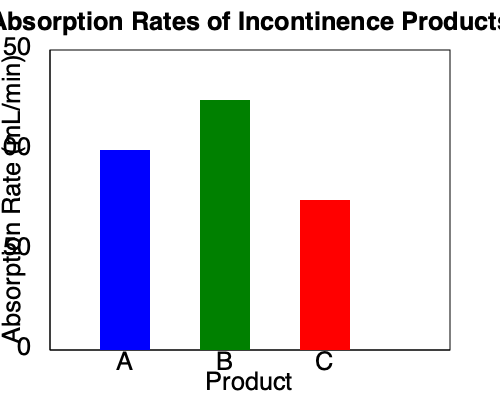Based on the bar graph comparing the absorption rates of different incontinence products, which product has the highest absorption rate, and what is the approximate difference in absorption rate between the best and worst performing products? To answer this question, we need to analyze the bar graph:

1. Identify the products:
   - Product A (blue bar)
   - Product B (green bar)
   - Product C (red bar)

2. Compare the heights of the bars:
   - Product A: Approximately 100 mL/min
   - Product B: Approximately 125 mL/min
   - Product C: Approximately 75 mL/min

3. Determine the product with the highest absorption rate:
   Product B has the tallest bar, indicating the highest absorption rate.

4. Calculate the difference between the best and worst performing products:
   - Best performing: Product B (125 mL/min)
   - Worst performing: Product C (75 mL/min)
   - Difference: 125 mL/min - 75 mL/min = 50 mL/min

Therefore, Product B has the highest absorption rate, and the approximate difference in absorption rate between the best (B) and worst (C) performing products is 50 mL/min.
Answer: Product B; 50 mL/min 